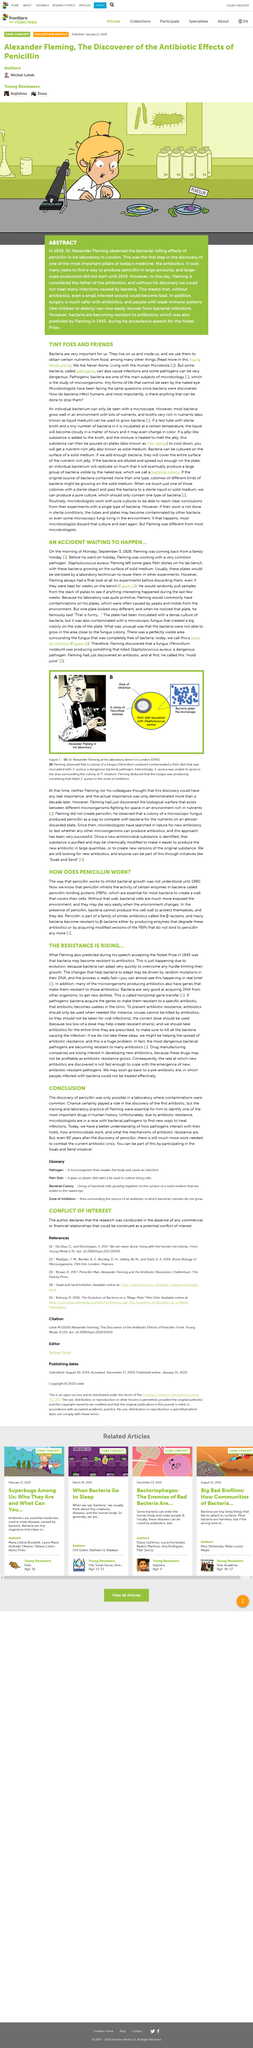Indicate a few pertinent items in this graphic. Microbiology is a field of study that focuses on the study of microorganisms, including their structure, function, behavior, and interactions with other organisms. One of the main subjects of microbiology is pathogenic bacteria, which are bacteria that are capable of causing disease in living organisms. In 1945, the Nobel Prize was awarded to Alexander Fleming for his pioneering work in the field of medicine. Sir Alexander Fleming is credited with discovering penicillin. One of the plates exhibited differences from the others in the way that the bacteria were unable to surround the area near the fungus colony. The article describes the problem of increasing bacterial resistance to antibiotics, which poses a significant threat to public health. 